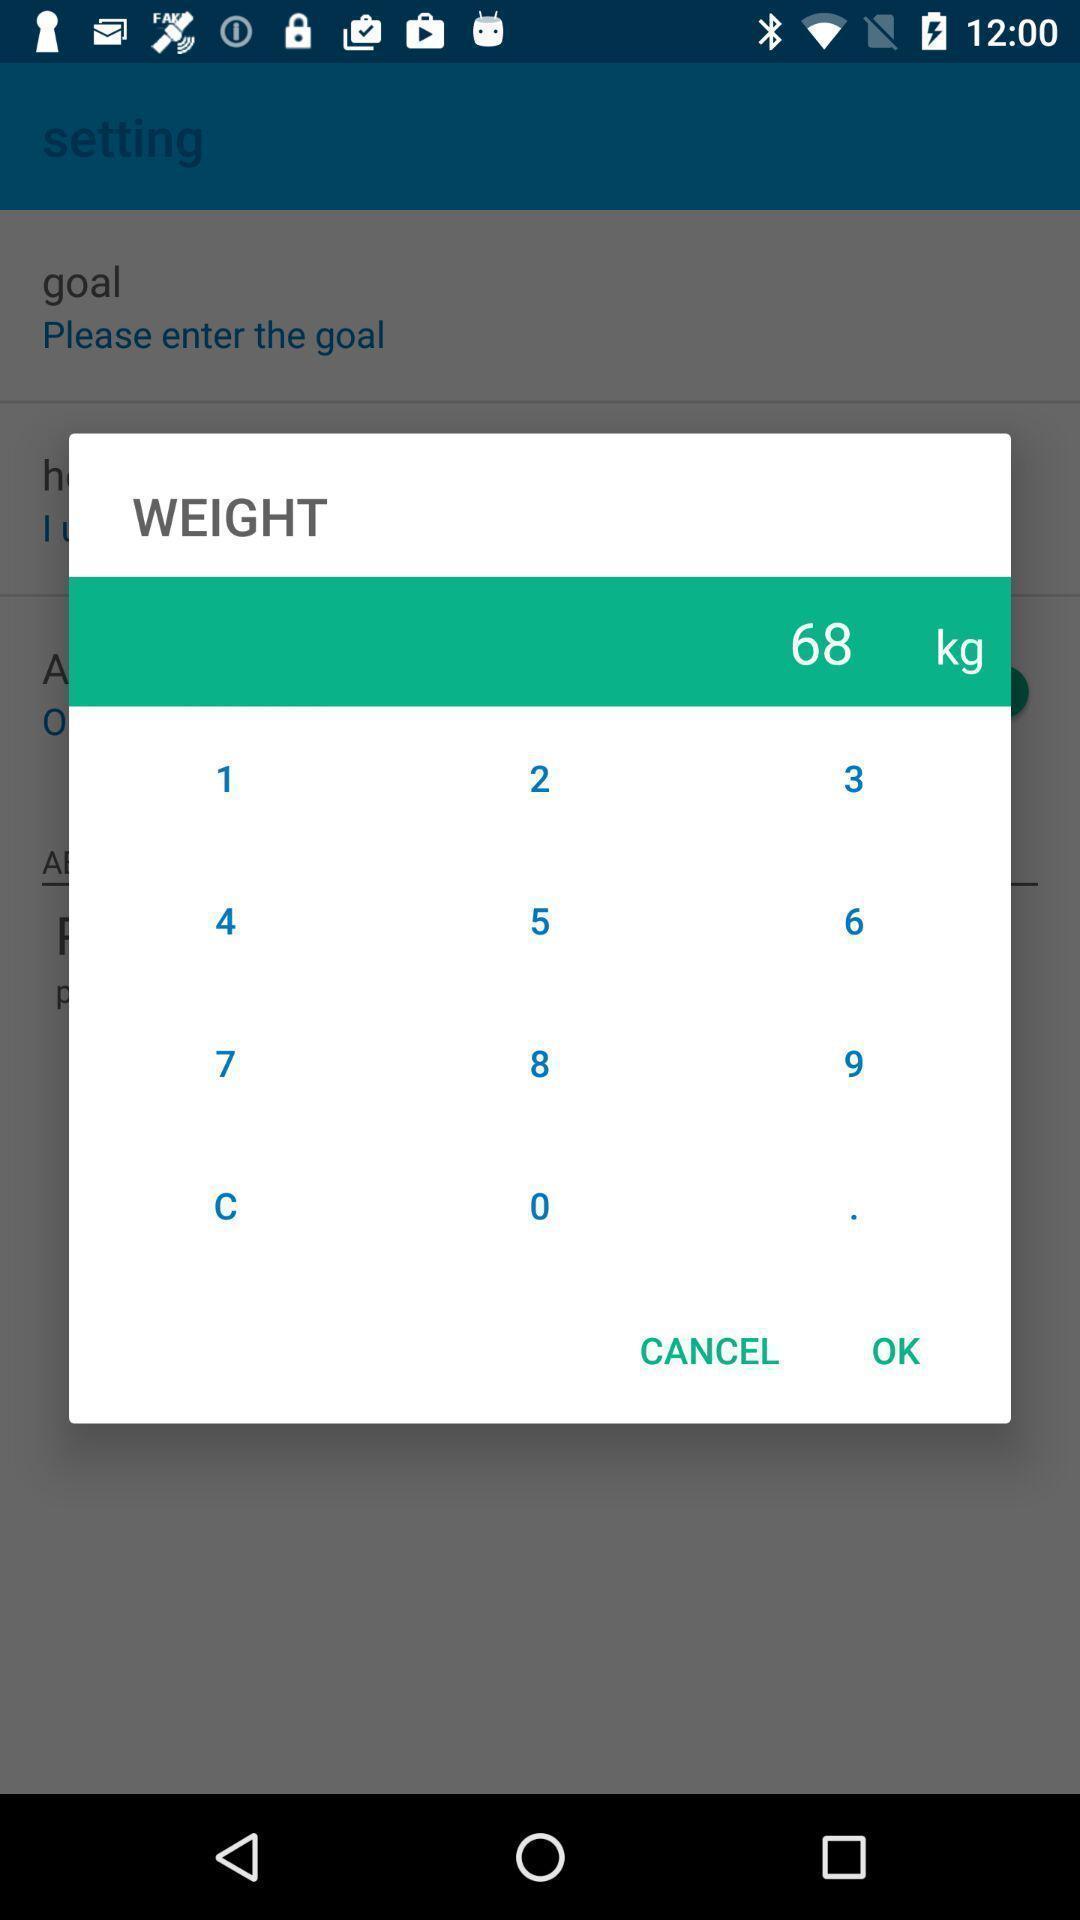What details can you identify in this image? Push up message asking to enter weight on fitness app. 